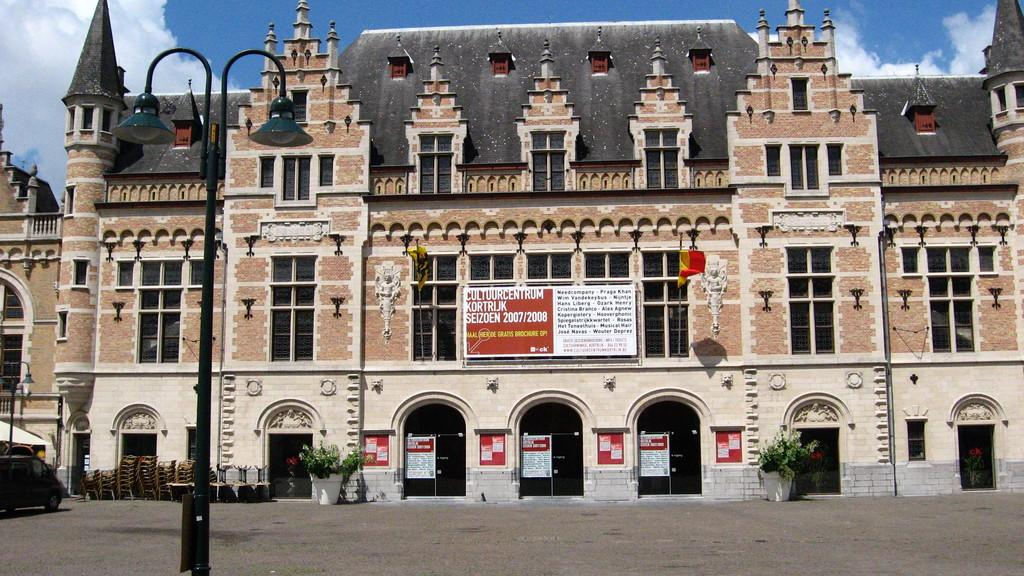What objects can be seen in the image that are used for support or stability? There are poles in the image that are used for support or stability. What type of furniture is present in the image? There are chairs in the image. What objects in the image provide illumination? There are lights in the image that provide illumination. What type of decorative items can be seen in the image? There are posters in the image. What surface is present in the image for writing or displaying information? There is a board in the image. What type of flags are visible in the image? There are flags in the image. What type of vehicle can be seen in the image? There is a car in the image. What type of openings are present in the building in the image? There are windows in the image. What type of structure is present in the image? There is a building in the image. What can be seen in the background of the image? The sky is visible in the background of the image, and there are clouds in the sky. What type of art can be seen on the plane in the image? There is no plane present in the image, so there is no art on a plane to be seen. 